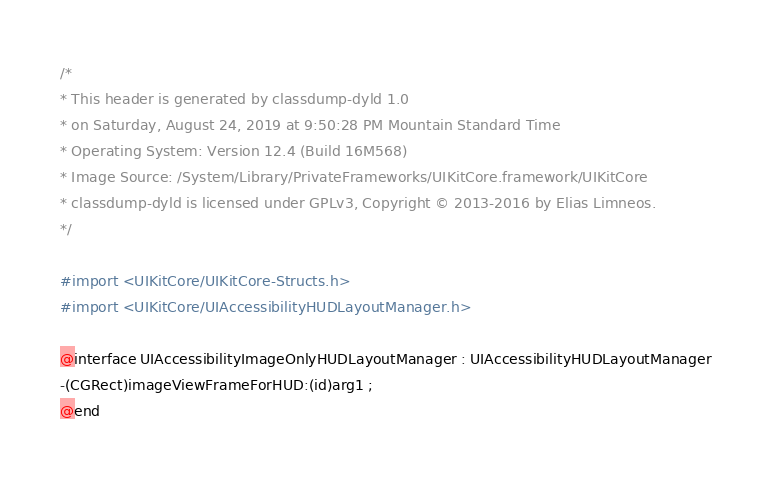<code> <loc_0><loc_0><loc_500><loc_500><_C_>/*
* This header is generated by classdump-dyld 1.0
* on Saturday, August 24, 2019 at 9:50:28 PM Mountain Standard Time
* Operating System: Version 12.4 (Build 16M568)
* Image Source: /System/Library/PrivateFrameworks/UIKitCore.framework/UIKitCore
* classdump-dyld is licensed under GPLv3, Copyright © 2013-2016 by Elias Limneos.
*/

#import <UIKitCore/UIKitCore-Structs.h>
#import <UIKitCore/UIAccessibilityHUDLayoutManager.h>

@interface UIAccessibilityImageOnlyHUDLayoutManager : UIAccessibilityHUDLayoutManager
-(CGRect)imageViewFrameForHUD:(id)arg1 ;
@end

</code> 